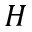<formula> <loc_0><loc_0><loc_500><loc_500>H</formula> 